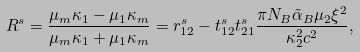Convert formula to latex. <formula><loc_0><loc_0><loc_500><loc_500>R ^ { s } = \frac { \mu _ { m } \kappa _ { 1 } - \mu _ { 1 } \kappa _ { m } } { \mu _ { m } \kappa _ { 1 } + \mu _ { 1 } \kappa _ { m } } = r ^ { s } _ { 1 2 } - t ^ { s } _ { 1 2 } t ^ { s } _ { 2 1 } \frac { \pi N _ { B } \tilde { \alpha } _ { B } \mu _ { 2 } \xi ^ { 2 } } { \kappa _ { 2 } ^ { 2 } c ^ { 2 } } ,</formula> 